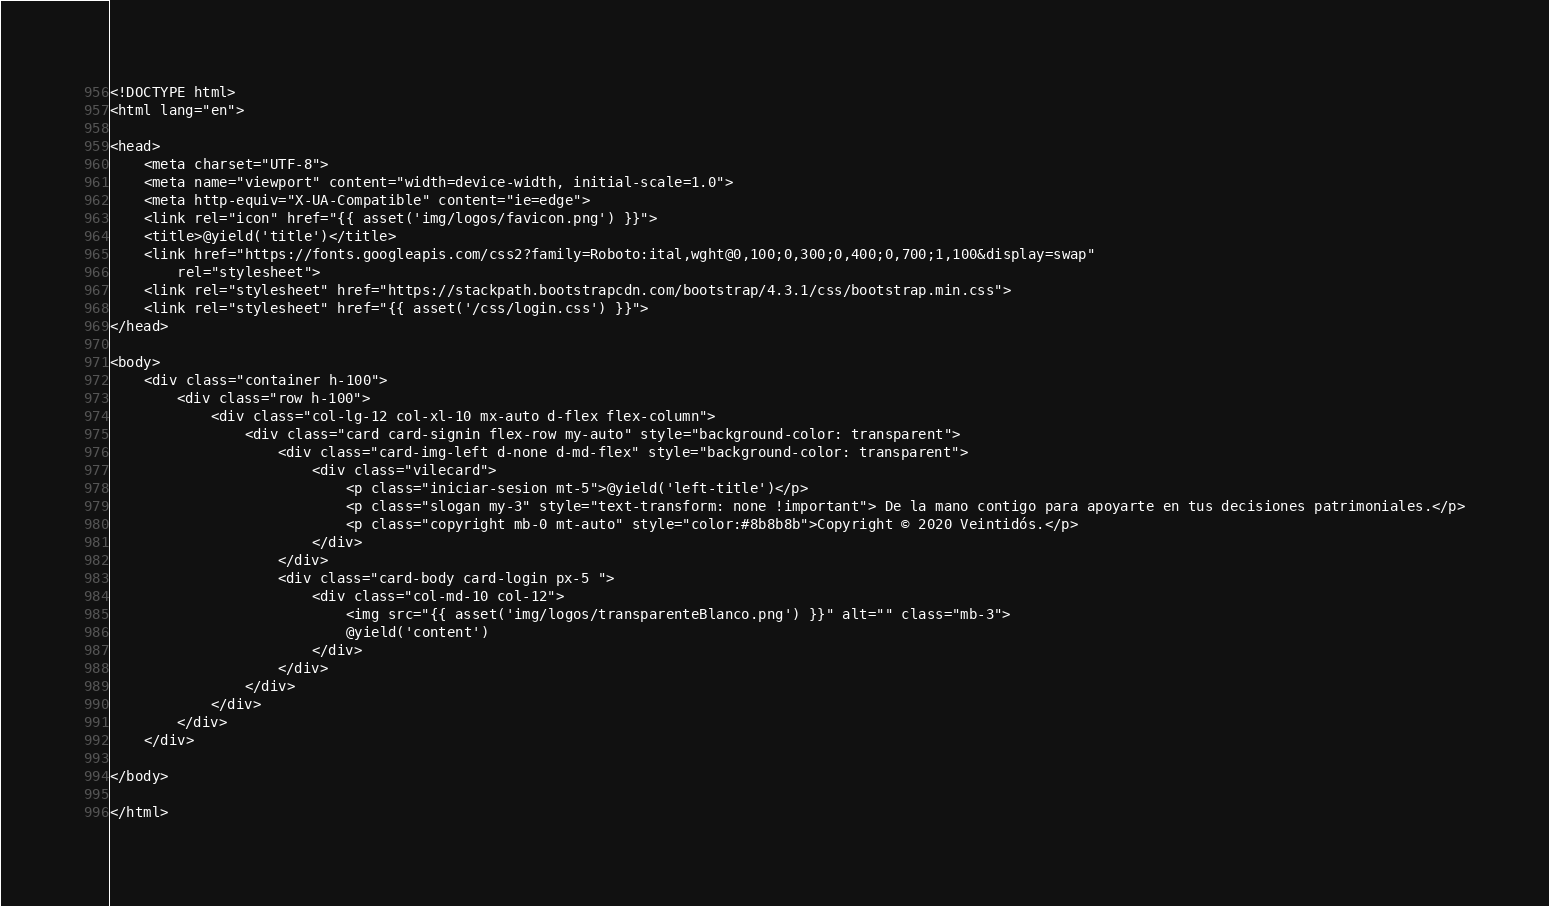<code> <loc_0><loc_0><loc_500><loc_500><_PHP_><!DOCTYPE html>
<html lang="en">

<head>
    <meta charset="UTF-8">
    <meta name="viewport" content="width=device-width, initial-scale=1.0">
    <meta http-equiv="X-UA-Compatible" content="ie=edge">
    <link rel="icon" href="{{ asset('img/logos/favicon.png') }}">
    <title>@yield('title')</title>
    <link href="https://fonts.googleapis.com/css2?family=Roboto:ital,wght@0,100;0,300;0,400;0,700;1,100&display=swap"
        rel="stylesheet">
    <link rel="stylesheet" href="https://stackpath.bootstrapcdn.com/bootstrap/4.3.1/css/bootstrap.min.css">
    <link rel="stylesheet" href="{{ asset('/css/login.css') }}">
</head>

<body>
    <div class="container h-100">
        <div class="row h-100">
            <div class="col-lg-12 col-xl-10 mx-auto d-flex flex-column">
                <div class="card card-signin flex-row my-auto" style="background-color: transparent">
                    <div class="card-img-left d-none d-md-flex" style="background-color: transparent">
                        <div class="vilecard">
                            <p class="iniciar-sesion mt-5">@yield('left-title')</p>
                            <p class="slogan my-3" style="text-transform: none !important"> De la mano contigo para apoyarte en tus decisiones patrimoniales.</p>
                            <p class="copyright mb-0 mt-auto" style="color:#8b8b8b">Copyright © 2020 Veintidós.</p>
                        </div>
                    </div>
                    <div class="card-body card-login px-5 ">
                        <div class="col-md-10 col-12">
                            <img src="{{ asset('img/logos/transparenteBlanco.png') }}" alt="" class="mb-3">
                            @yield('content')
                        </div>
                    </div>
                </div>
            </div>
        </div>
    </div>

</body>

</html></code> 